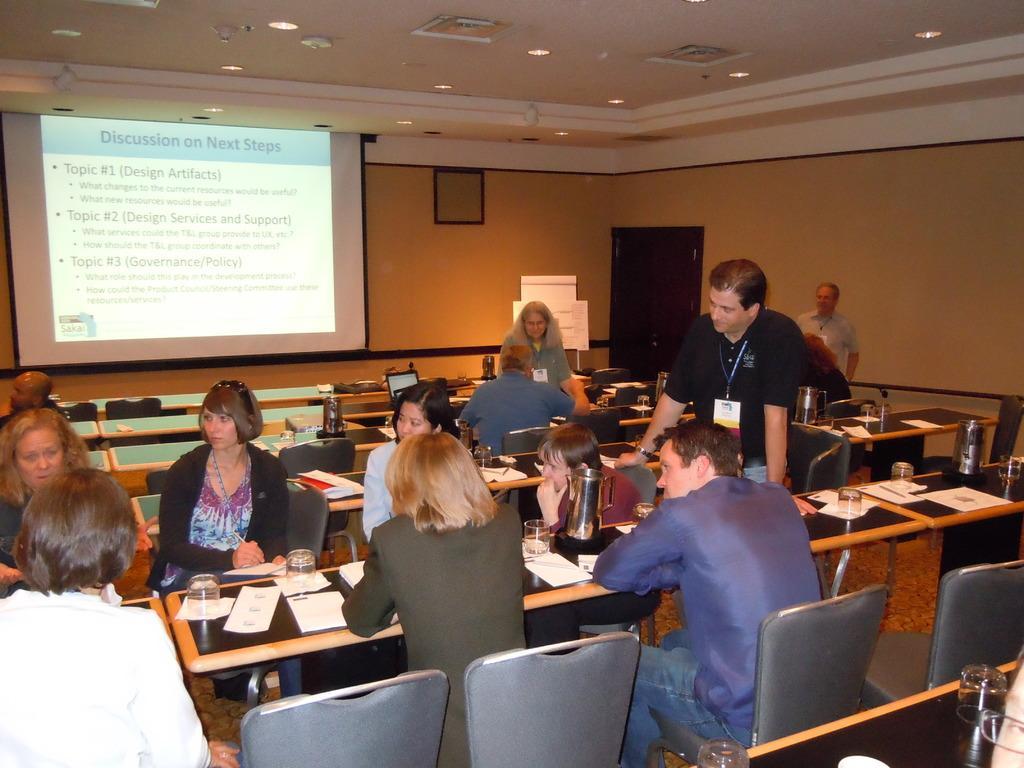How would you summarize this image in a sentence or two? This is a picture in a seminar hall. There are group of people sitting on a chairs in front of them there is a table on the table there is a glass and the paper and laptops also. Background of them there is a projector screen and a wall. On top of them there is a roof with lights. 